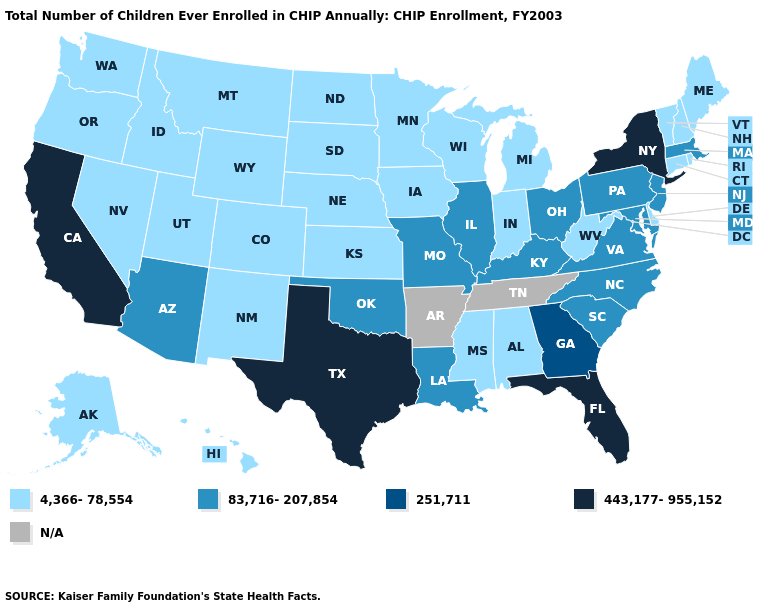Is the legend a continuous bar?
Quick response, please. No. What is the value of Mississippi?
Quick response, please. 4,366-78,554. What is the lowest value in the Northeast?
Keep it brief. 4,366-78,554. What is the value of South Carolina?
Give a very brief answer. 83,716-207,854. Among the states that border South Carolina , which have the highest value?
Keep it brief. Georgia. What is the value of Washington?
Concise answer only. 4,366-78,554. What is the value of Texas?
Short answer required. 443,177-955,152. Among the states that border Oklahoma , does Missouri have the highest value?
Concise answer only. No. Which states have the highest value in the USA?
Quick response, please. California, Florida, New York, Texas. What is the value of Massachusetts?
Quick response, please. 83,716-207,854. Does Texas have the highest value in the USA?
Quick response, please. Yes. What is the value of Montana?
Answer briefly. 4,366-78,554. Does Virginia have the lowest value in the USA?
Keep it brief. No. Does Arizona have the lowest value in the USA?
Be succinct. No. Does Missouri have the highest value in the MidWest?
Keep it brief. Yes. 